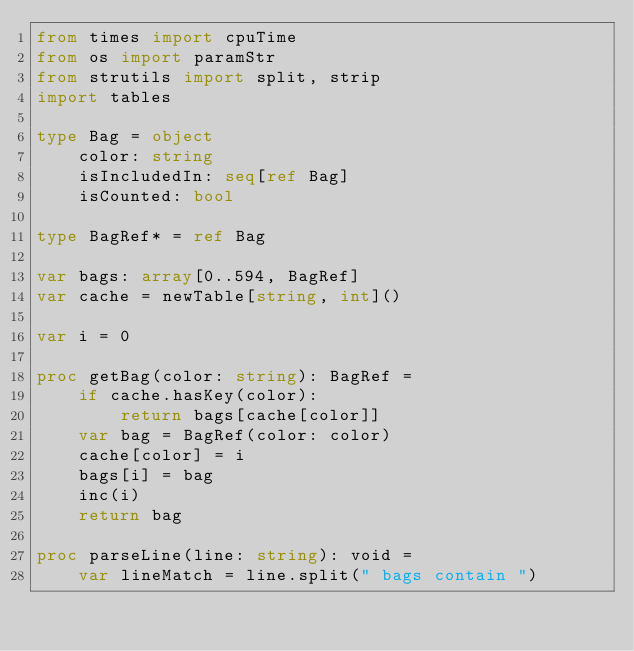<code> <loc_0><loc_0><loc_500><loc_500><_Nim_>from times import cpuTime
from os import paramStr
from strutils import split, strip
import tables

type Bag = object
    color: string
    isIncludedIn: seq[ref Bag]
    isCounted: bool

type BagRef* = ref Bag

var bags: array[0..594, BagRef]
var cache = newTable[string, int]()

var i = 0

proc getBag(color: string): BagRef =
    if cache.hasKey(color):
        return bags[cache[color]]
    var bag = BagRef(color: color)
    cache[color] = i
    bags[i] = bag
    inc(i)
    return bag

proc parseLine(line: string): void =
    var lineMatch = line.split(" bags contain ")</code> 